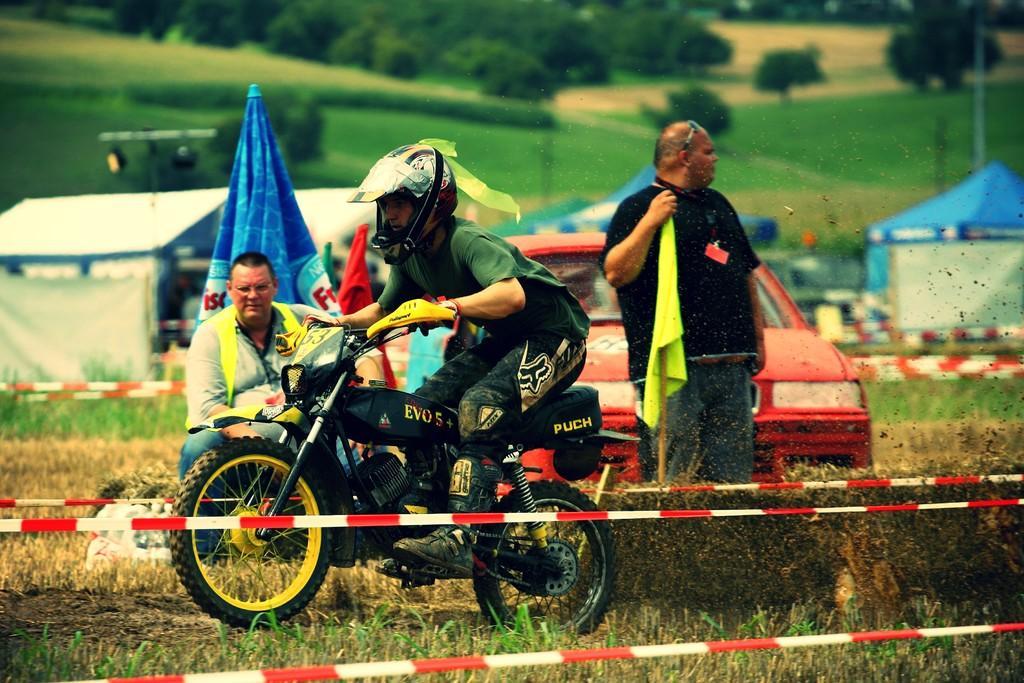Please provide a concise description of this image. This person standing and holding flag and This person sitting and this person riding bike and wear helmet. On the background we can see trees,tents. We can see vehicle. 